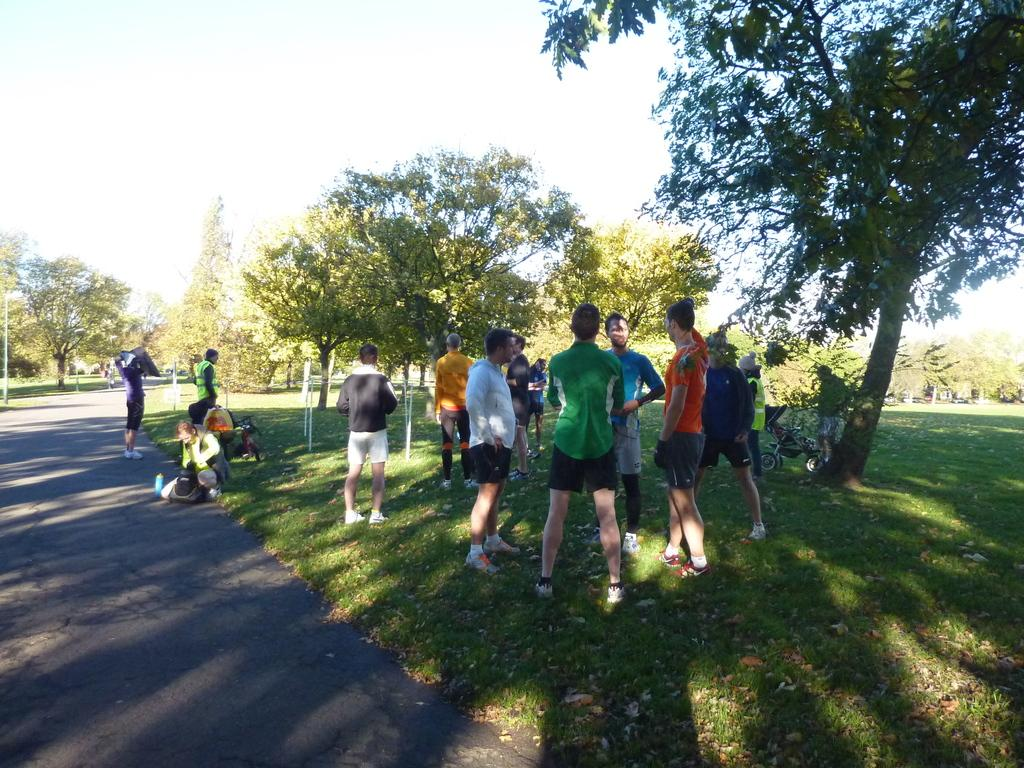How many people are in the image? There are people in the image, but the exact number is not specified. What are the people doing in the image? The people are standing in the image. What type of terrain is visible in the image? There is grass visible in the image, which suggests a grassy area or field. What type of man-made structure can be seen in the image? There is a road in the image, which is a man-made structure for transportation. What natural elements are present in the image? There are trees and the sky visible in the image, which are natural elements. What type of butter is being used to create memories in the image? There is no butter or memory creation activity present in the image. How does the wind blow in the image? There is no mention of wind or blowing in the image. 